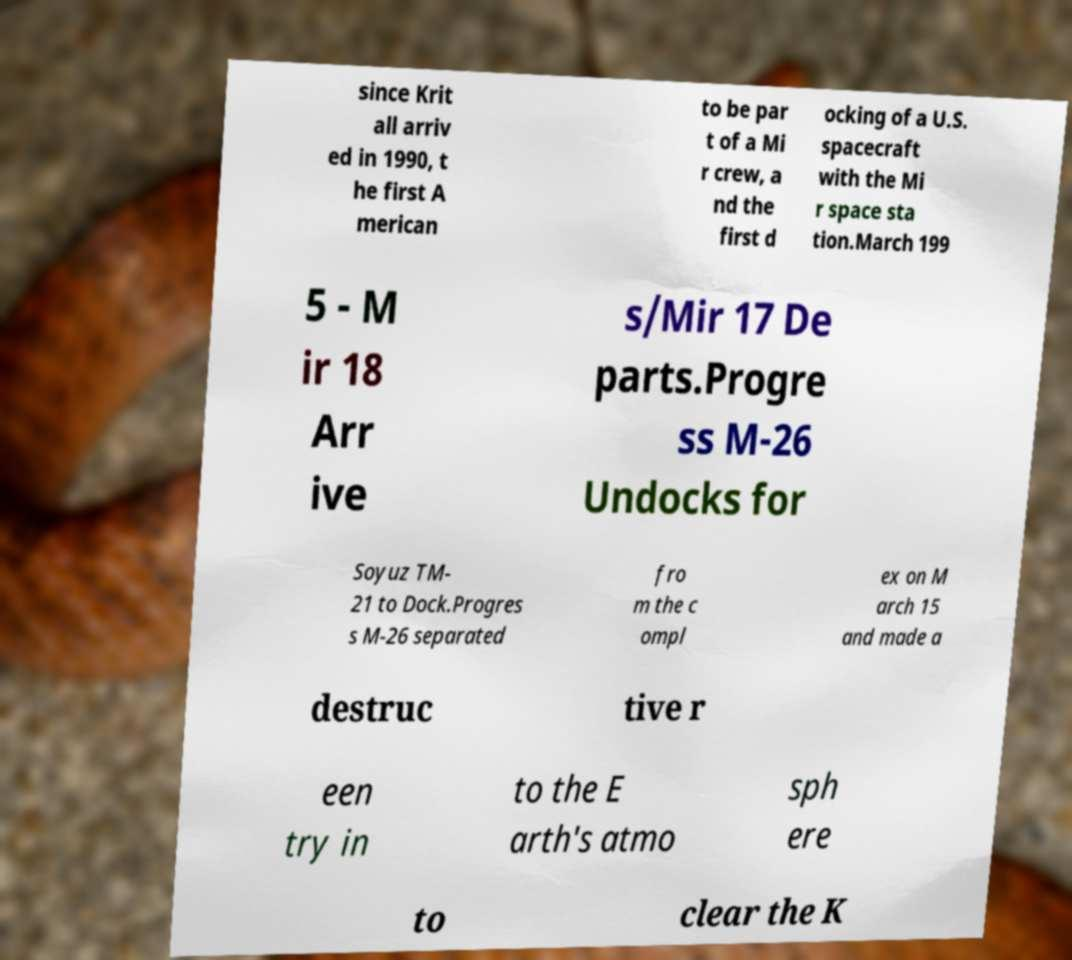Could you extract and type out the text from this image? since Krit all arriv ed in 1990, t he first A merican to be par t of a Mi r crew, a nd the first d ocking of a U.S. spacecraft with the Mi r space sta tion.March 199 5 - M ir 18 Arr ive s/Mir 17 De parts.Progre ss M-26 Undocks for Soyuz TM- 21 to Dock.Progres s M-26 separated fro m the c ompl ex on M arch 15 and made a destruc tive r een try in to the E arth's atmo sph ere to clear the K 